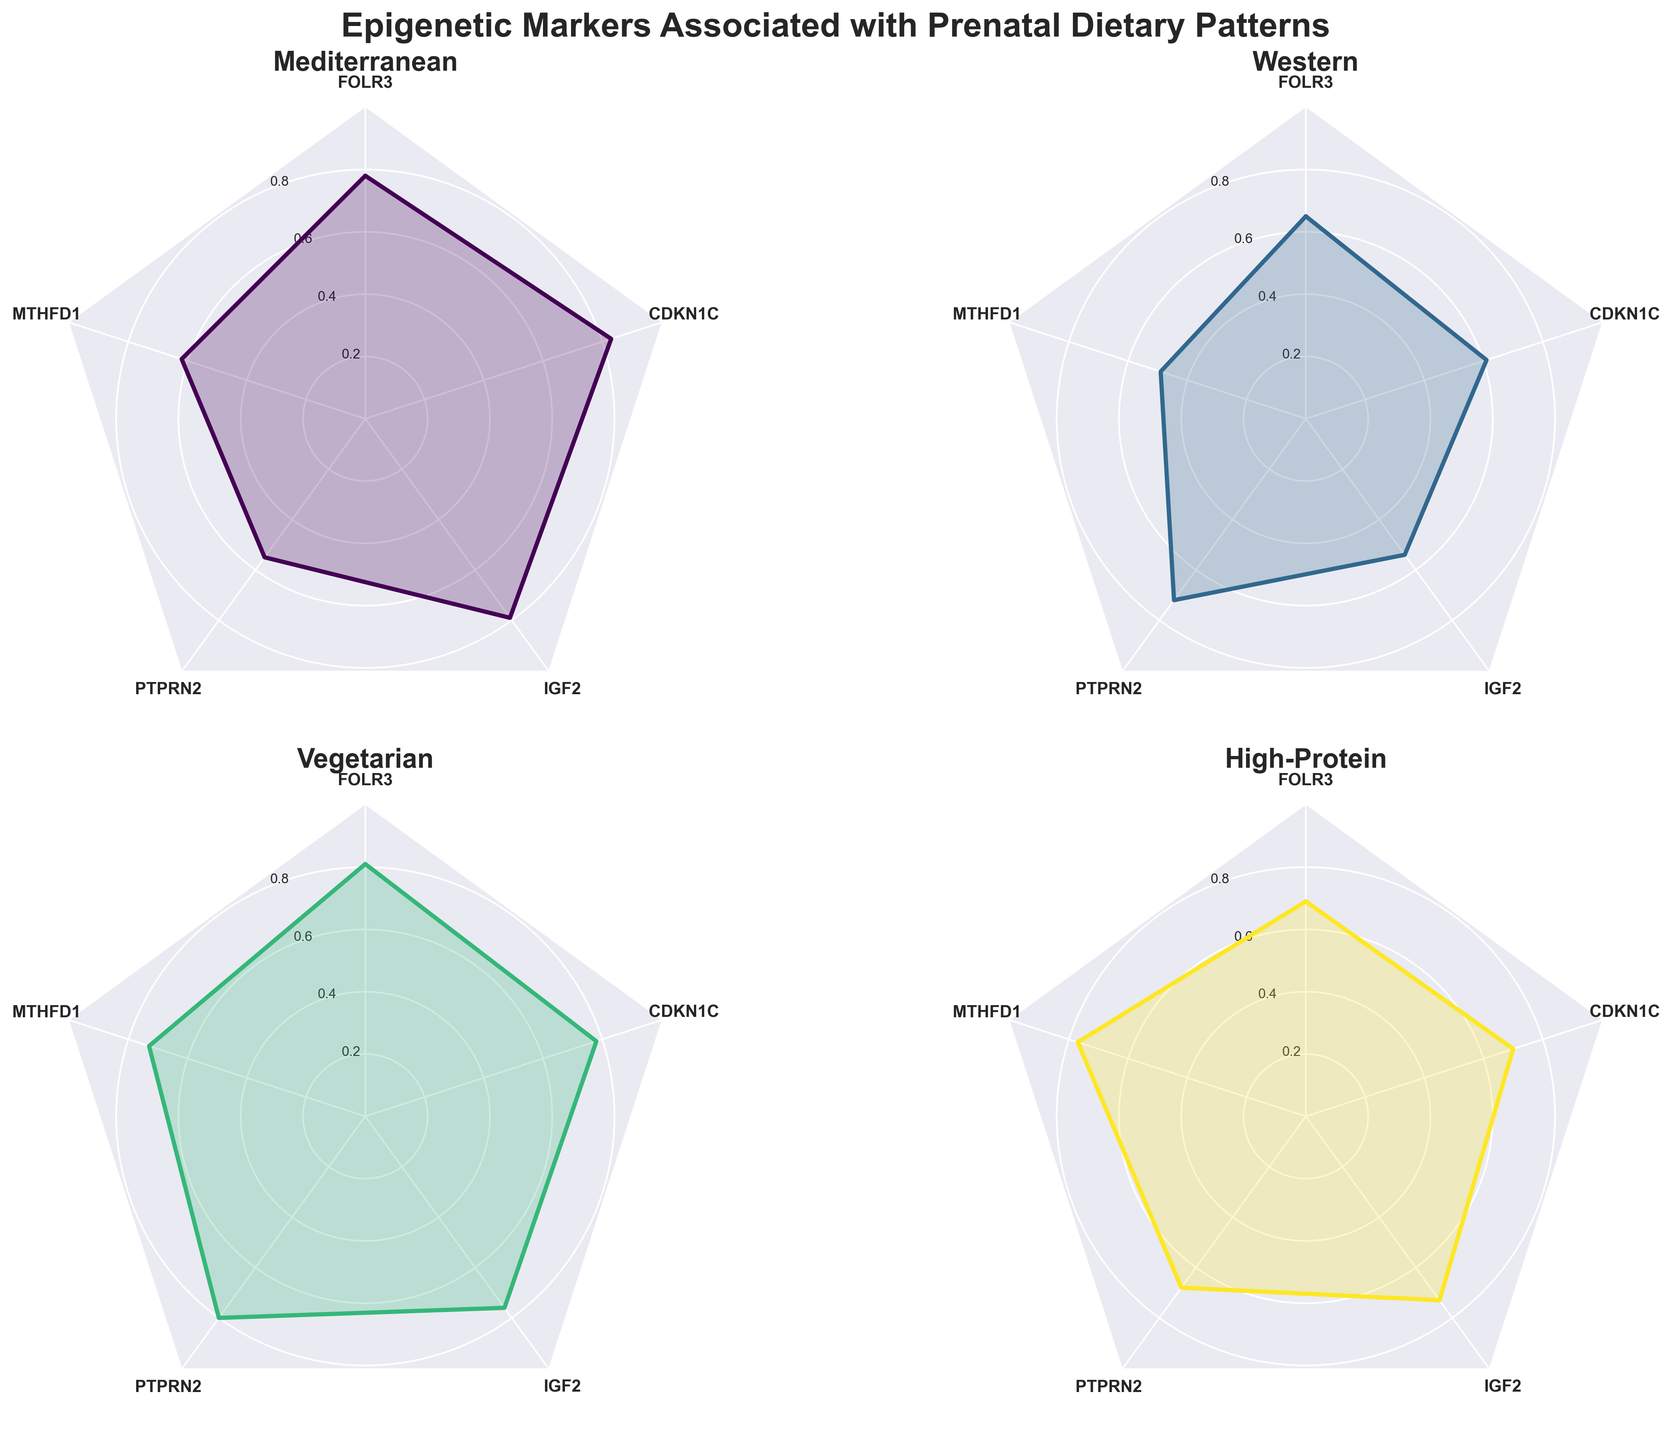What is the title of the figure? The title is typically found at the top of the figure. It summarizes what the entire figure is about. This one reads "Epigenetic Markers Associated with Prenatal Dietary Patterns".
Answer: Epigenetic Markers Associated with Prenatal Dietary Patterns How many dietary patterns are compared in the figure? The figure contains four subplots, each representing a different dietary pattern. By counting them, you see Mediterranean, Western, Vegetarian, and High-Protein diets.
Answer: Four Which dietary pattern shows the highest value for DNAmM1? By comparing the radar plots for DNAmM1 across all subplots, the Mediterranean diet shows the highest value, approximately 0.78.
Answer: Mediterranean What is the range of the radial gridlines in each subplot? The radial gridlines serve as reference values. Reading the labels on the gridlines, they range from 0.2 to 0.8.
Answer: 0.2 to 0.8 Which two markers in the Vegetarian diet have the closest values? By examining the radar plot for the Vegetarian diet and comparing the data points visually, DNAmM3 and DNAmM5 both have values close to 0.78 and 0.76 respectively.
Answer: DNAmM3 and DNAmM5 Which dietary pattern has the most variable values? Variability can be assessed by the spread of the data points in the radar plot. The Western diet shows a wider spread in values ranging from 0.49 to 0.72.
Answer: Western Among the Mediterranean and High-Protein diets, which one shows a higher average value across all markers? Calculate the average for each diet:
Mediterranean: (0.78+0.62+0.55+0.79+0.83)/5 = 0.714;
High-Protein: (0.69+0.77+0.68+0.73+0.70)/5 = 0.714.
Both show similar averages, but the courses of slight decimal points may differ insignificantly.
Answer: Similar Which marker is associated with high values across most dietary patterns? Visually inspecting the radar plots, DNAmM1 has consistently high values across Mediterranean (0.78), Vegetarian (0.81), and High-Protein (0.69) diets.
Answer: DNAmM1 For the Western diet, which marker would you say is the least influential in the plot? Looking at the radar plot for the Western diet, DNAmM2 has the lowest value at 0.49, making it the least influential marker.
Answer: DNAmM2 What is the difference in the DNAmM4 value between the Mediterranean and High-Protein diets? Subtract the DNAmM4 value of the High-Protein diet from that of the Mediterranean diet: 0.79 - 0.73 = 0.06.
Answer: 0.06 